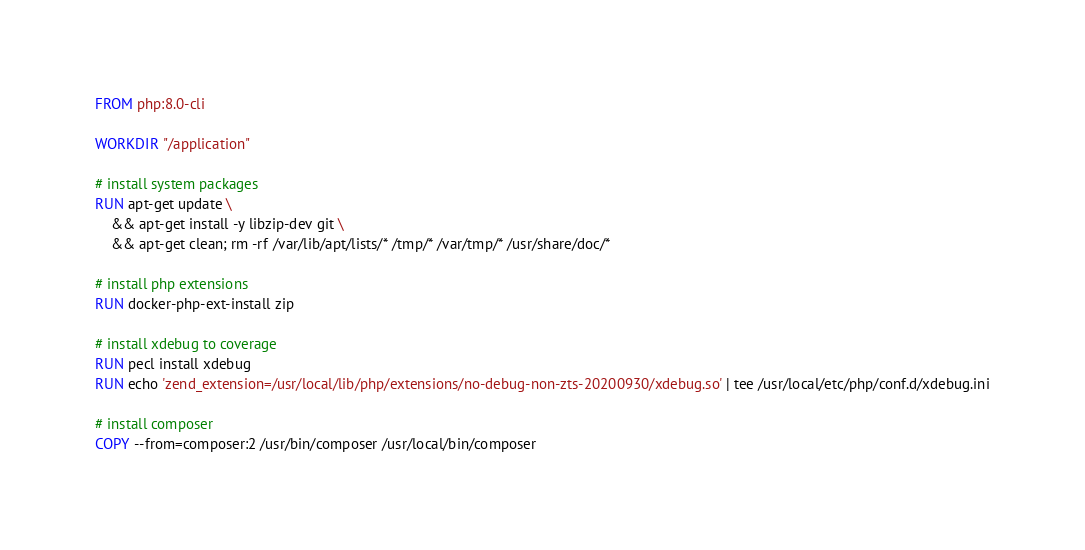<code> <loc_0><loc_0><loc_500><loc_500><_Dockerfile_>FROM php:8.0-cli

WORKDIR "/application"

# install system packages
RUN apt-get update \
    && apt-get install -y libzip-dev git \
    && apt-get clean; rm -rf /var/lib/apt/lists/* /tmp/* /var/tmp/* /usr/share/doc/*

# install php extensions
RUN docker-php-ext-install zip

# install xdebug to coverage
RUN pecl install xdebug
RUN echo 'zend_extension=/usr/local/lib/php/extensions/no-debug-non-zts-20200930/xdebug.so' | tee /usr/local/etc/php/conf.d/xdebug.ini

# install composer
COPY --from=composer:2 /usr/bin/composer /usr/local/bin/composer
</code> 